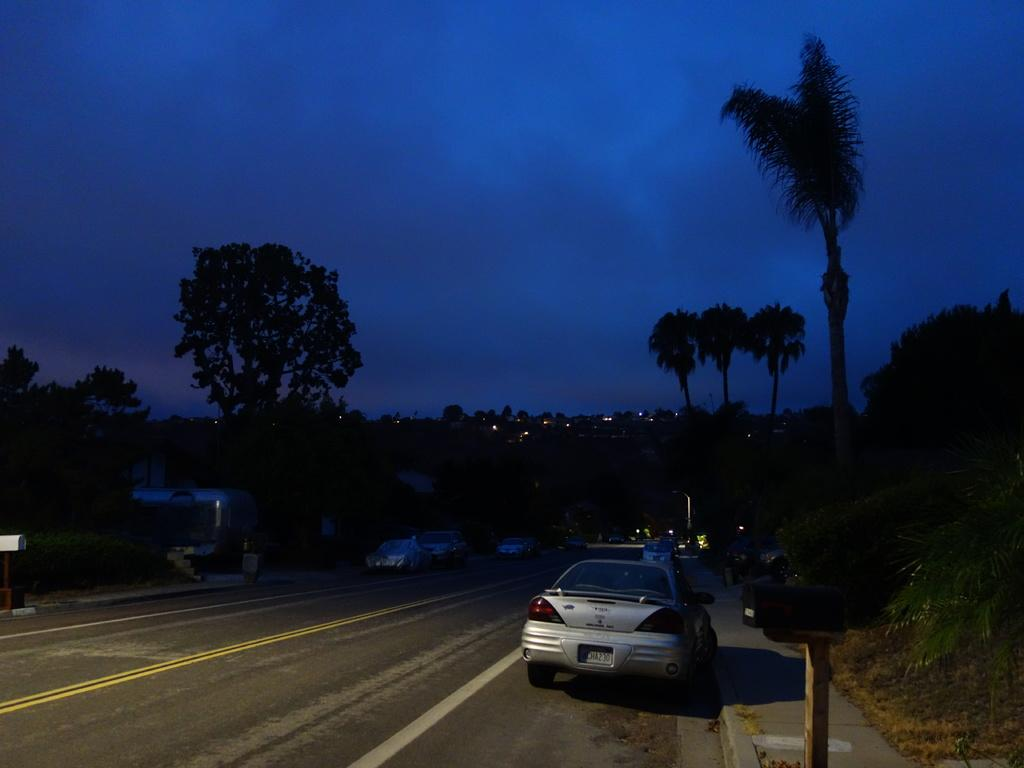Where was the image taken? The image was clicked outside. What can be seen in the middle of the image? There are trees in the middle of the image. What type of vehicle is at the bottom of the image? There is a car at the bottom of the image. What is visible at the top of the image? The sky is visible at the top of the image. What type of property is visible in the wilderness in the image? There is no property visible in the wilderness in the image, as the image does not depict a wilderness setting. 